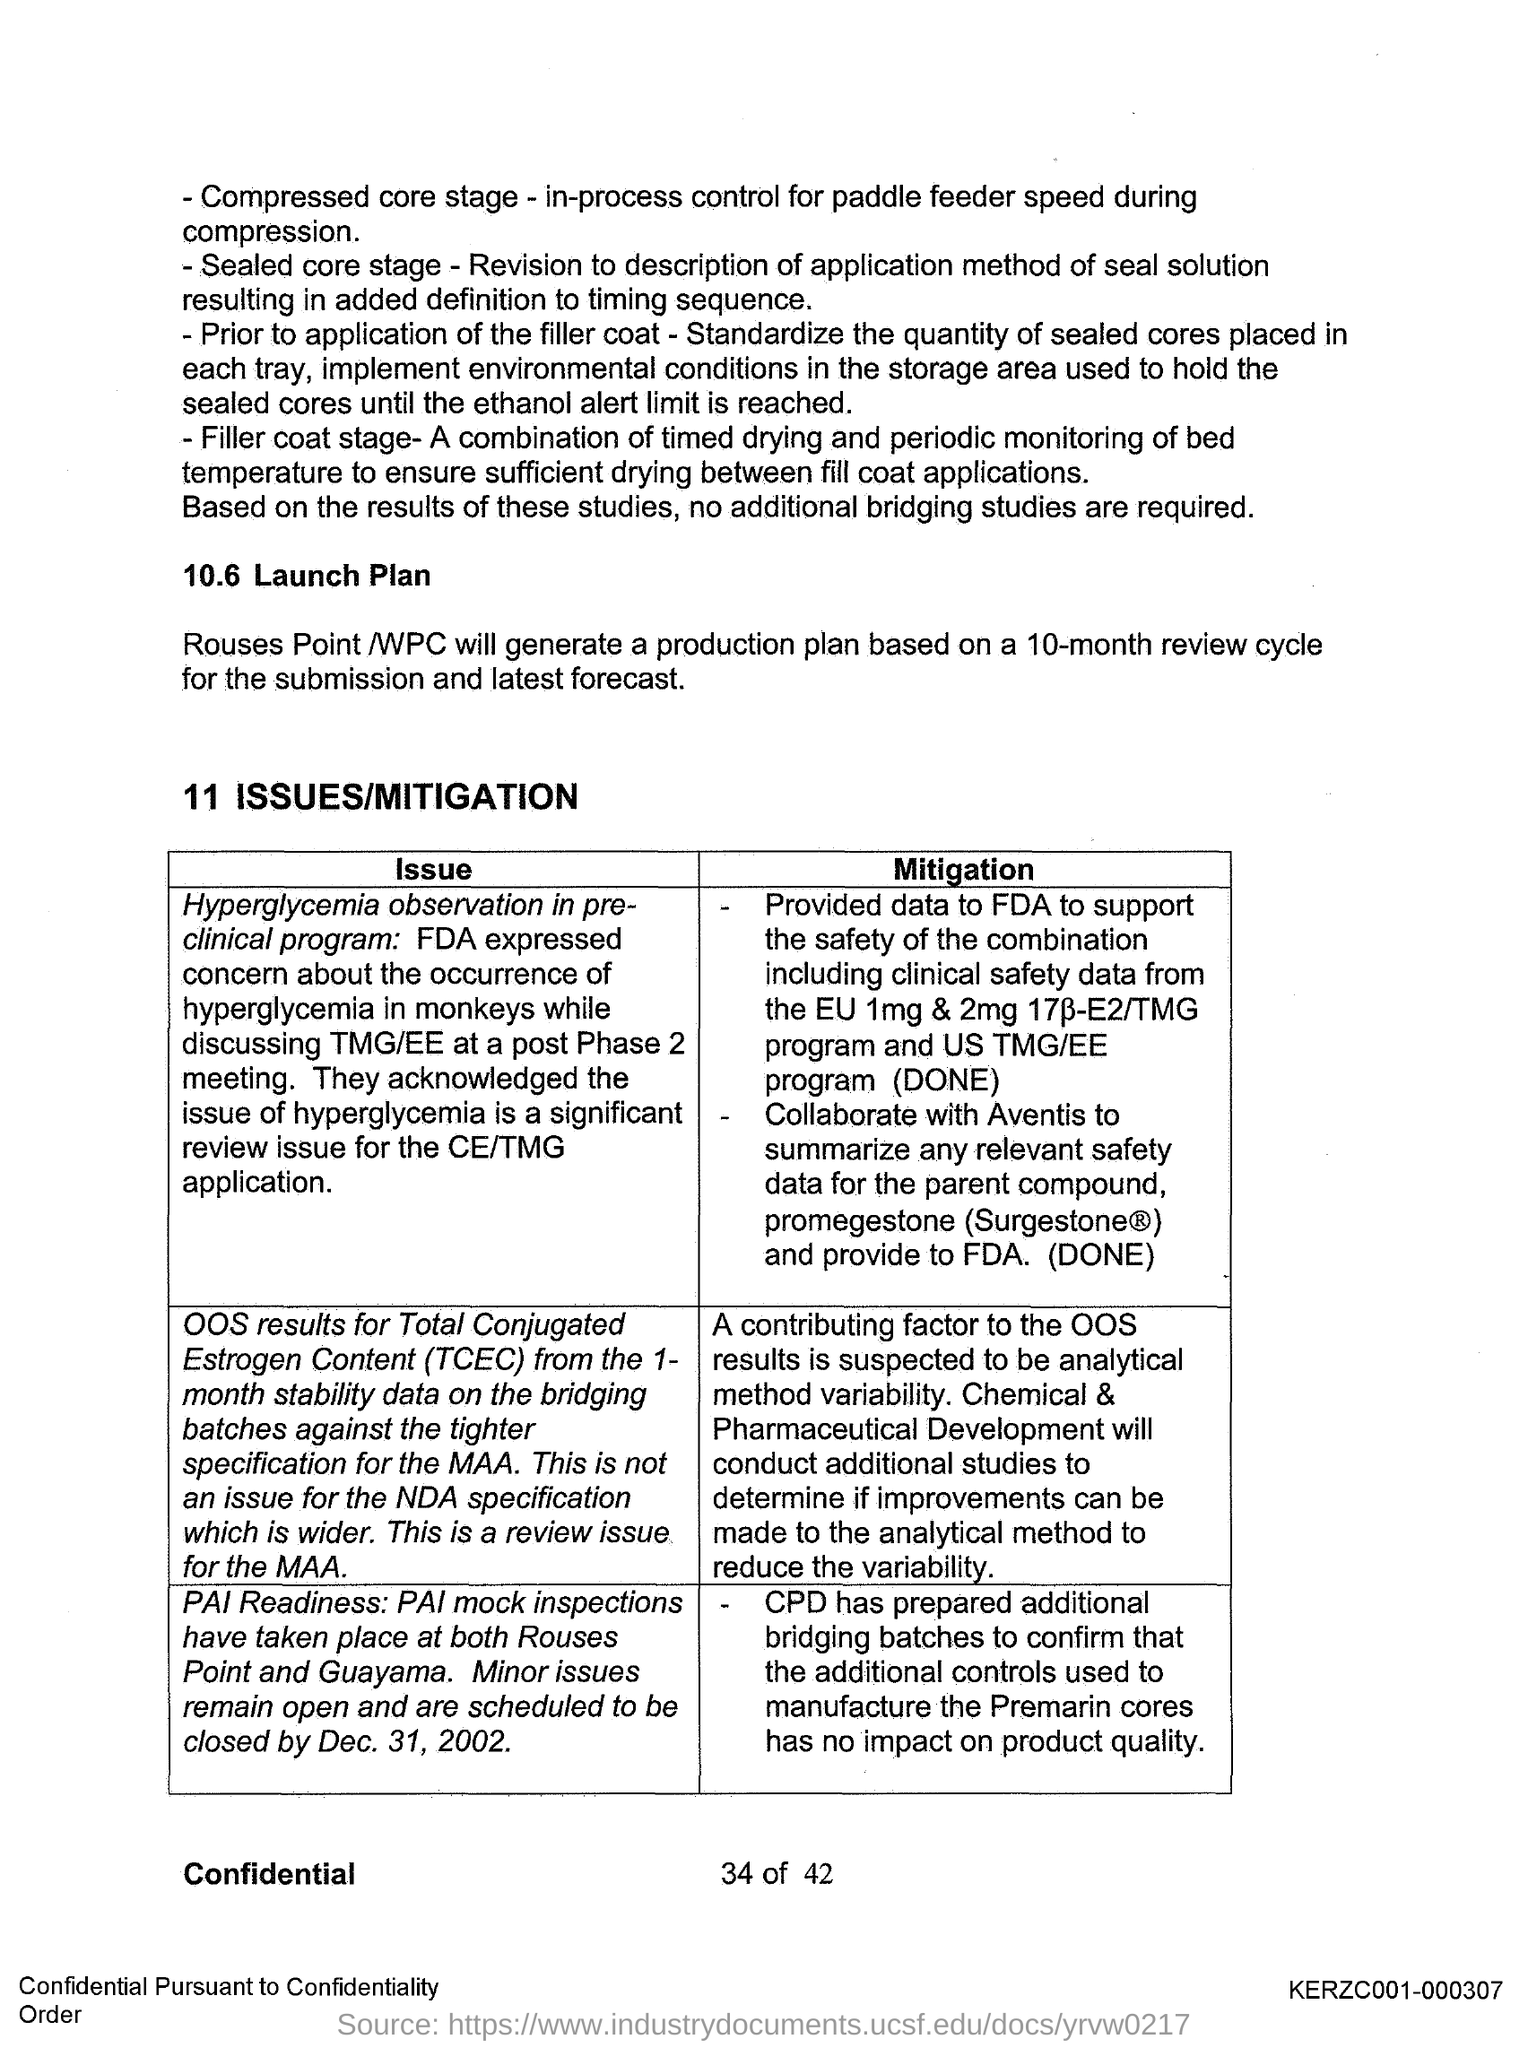Identify some key points in this picture. The full form of TCEC is Total Conjugated Estrogen Content, which refers to the measurement of the amount of a specific type of estrogen found in a substance or product. 